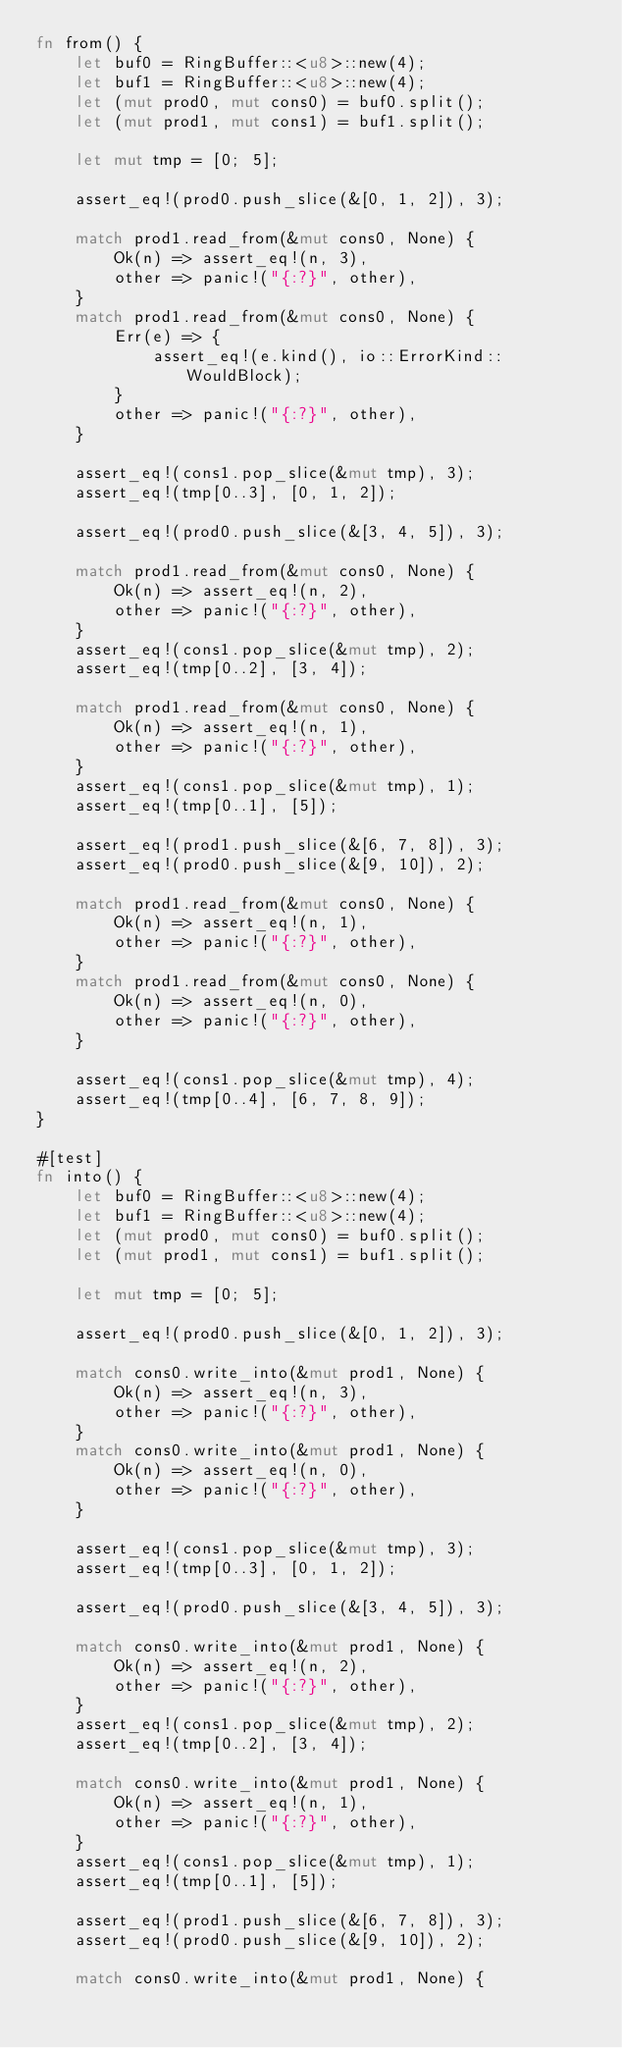<code> <loc_0><loc_0><loc_500><loc_500><_Rust_>fn from() {
    let buf0 = RingBuffer::<u8>::new(4);
    let buf1 = RingBuffer::<u8>::new(4);
    let (mut prod0, mut cons0) = buf0.split();
    let (mut prod1, mut cons1) = buf1.split();

    let mut tmp = [0; 5];

    assert_eq!(prod0.push_slice(&[0, 1, 2]), 3);

    match prod1.read_from(&mut cons0, None) {
        Ok(n) => assert_eq!(n, 3),
        other => panic!("{:?}", other),
    }
    match prod1.read_from(&mut cons0, None) {
        Err(e) => {
            assert_eq!(e.kind(), io::ErrorKind::WouldBlock);
        }
        other => panic!("{:?}", other),
    }

    assert_eq!(cons1.pop_slice(&mut tmp), 3);
    assert_eq!(tmp[0..3], [0, 1, 2]);

    assert_eq!(prod0.push_slice(&[3, 4, 5]), 3);

    match prod1.read_from(&mut cons0, None) {
        Ok(n) => assert_eq!(n, 2),
        other => panic!("{:?}", other),
    }
    assert_eq!(cons1.pop_slice(&mut tmp), 2);
    assert_eq!(tmp[0..2], [3, 4]);

    match prod1.read_from(&mut cons0, None) {
        Ok(n) => assert_eq!(n, 1),
        other => panic!("{:?}", other),
    }
    assert_eq!(cons1.pop_slice(&mut tmp), 1);
    assert_eq!(tmp[0..1], [5]);

    assert_eq!(prod1.push_slice(&[6, 7, 8]), 3);
    assert_eq!(prod0.push_slice(&[9, 10]), 2);

    match prod1.read_from(&mut cons0, None) {
        Ok(n) => assert_eq!(n, 1),
        other => panic!("{:?}", other),
    }
    match prod1.read_from(&mut cons0, None) {
        Ok(n) => assert_eq!(n, 0),
        other => panic!("{:?}", other),
    }

    assert_eq!(cons1.pop_slice(&mut tmp), 4);
    assert_eq!(tmp[0..4], [6, 7, 8, 9]);
}

#[test]
fn into() {
    let buf0 = RingBuffer::<u8>::new(4);
    let buf1 = RingBuffer::<u8>::new(4);
    let (mut prod0, mut cons0) = buf0.split();
    let (mut prod1, mut cons1) = buf1.split();

    let mut tmp = [0; 5];

    assert_eq!(prod0.push_slice(&[0, 1, 2]), 3);

    match cons0.write_into(&mut prod1, None) {
        Ok(n) => assert_eq!(n, 3),
        other => panic!("{:?}", other),
    }
    match cons0.write_into(&mut prod1, None) {
        Ok(n) => assert_eq!(n, 0),
        other => panic!("{:?}", other),
    }

    assert_eq!(cons1.pop_slice(&mut tmp), 3);
    assert_eq!(tmp[0..3], [0, 1, 2]);

    assert_eq!(prod0.push_slice(&[3, 4, 5]), 3);

    match cons0.write_into(&mut prod1, None) {
        Ok(n) => assert_eq!(n, 2),
        other => panic!("{:?}", other),
    }
    assert_eq!(cons1.pop_slice(&mut tmp), 2);
    assert_eq!(tmp[0..2], [3, 4]);

    match cons0.write_into(&mut prod1, None) {
        Ok(n) => assert_eq!(n, 1),
        other => panic!("{:?}", other),
    }
    assert_eq!(cons1.pop_slice(&mut tmp), 1);
    assert_eq!(tmp[0..1], [5]);

    assert_eq!(prod1.push_slice(&[6, 7, 8]), 3);
    assert_eq!(prod0.push_slice(&[9, 10]), 2);

    match cons0.write_into(&mut prod1, None) {</code> 